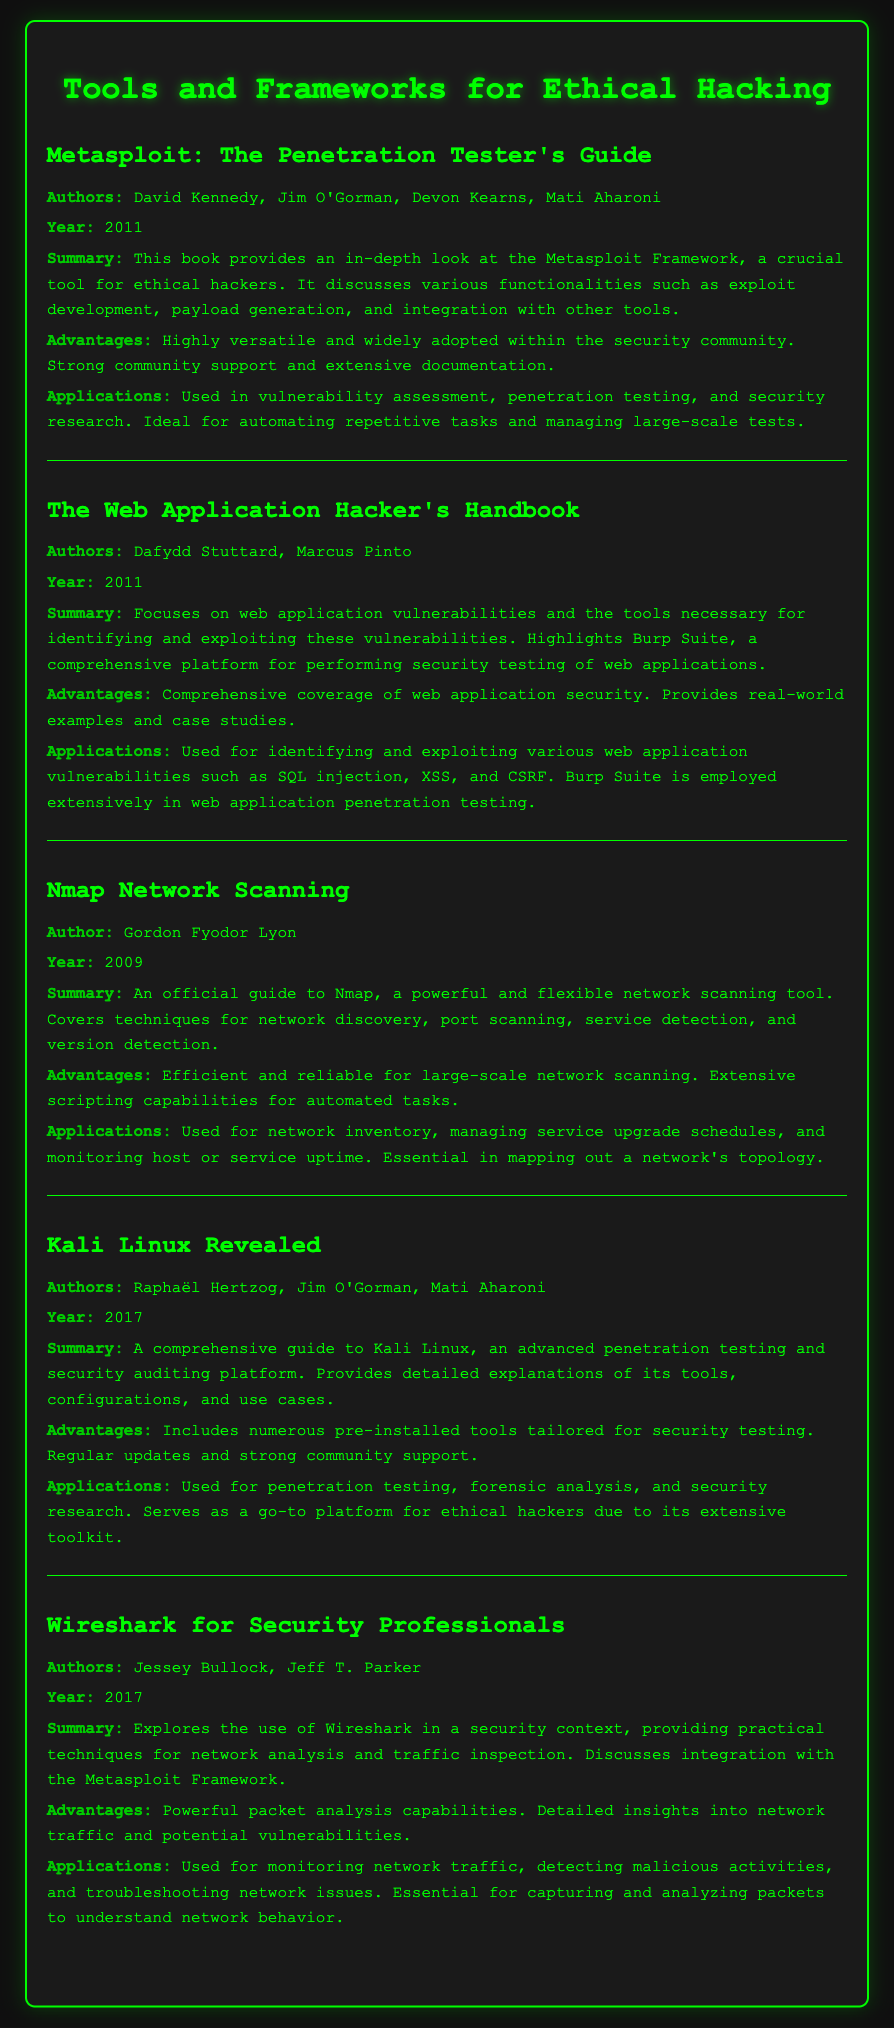What is the title of the first book listed? The title of the first book listed in the document is located at the beginning of the entry for Metasploit, which is "Metasploit: The Penetration Tester's Guide."
Answer: Metasploit: The Penetration Tester's Guide Who are the authors of "The Web Application Hacker's Handbook"? The authors of "The Web Application Hacker's Handbook" are mentioned in the summary section of the entry. They are Dafydd Stuttard and Marcus Pinto.
Answer: Dafydd Stuttard, Marcus Pinto What year was "Nmap Network Scanning" published? The year of publication is provided in the entry for Nmap Network Scanning, which states the year as 2009.
Answer: 2009 What is one advantage of using Metasploit? The advantages of Metasploit are listed in the respective section of its entry, mentioning it is highly versatile and widely adopted.
Answer: Highly versatile How many authors contributed to "Kali Linux Revealed"? To find the number of authors, one must refer to the authors' section of the book entry, which lists three names: Raphaël Hertzog, Jim O'Gorman, and Mati Aharoni.
Answer: Three What application is mentioned for using Wireshark in the document? The applications for Wireshark are detailed in the respective section of its entry, indicating it is used for monitoring network traffic.
Answer: Monitoring network traffic What is one key functionality of Burp Suite as noted in the document? The key functionality of Burp Suite is highlighted in the summary of "The Web Application Hacker's Handbook," mentioning that it is comprehensive for performing security testing of web applications.
Answer: Security testing of web applications What type of document is being summarized in this HTML? The type of document is specified at the start, indicating it is an annotated bibliography.
Answer: Annotated bibliography Which book focuses specifically on web application vulnerabilities? By analyzing the entries, one can conclude that "The Web Application Hacker's Handbook" directly targets web application vulnerabilities.
Answer: The Web Application Hacker's Handbook 